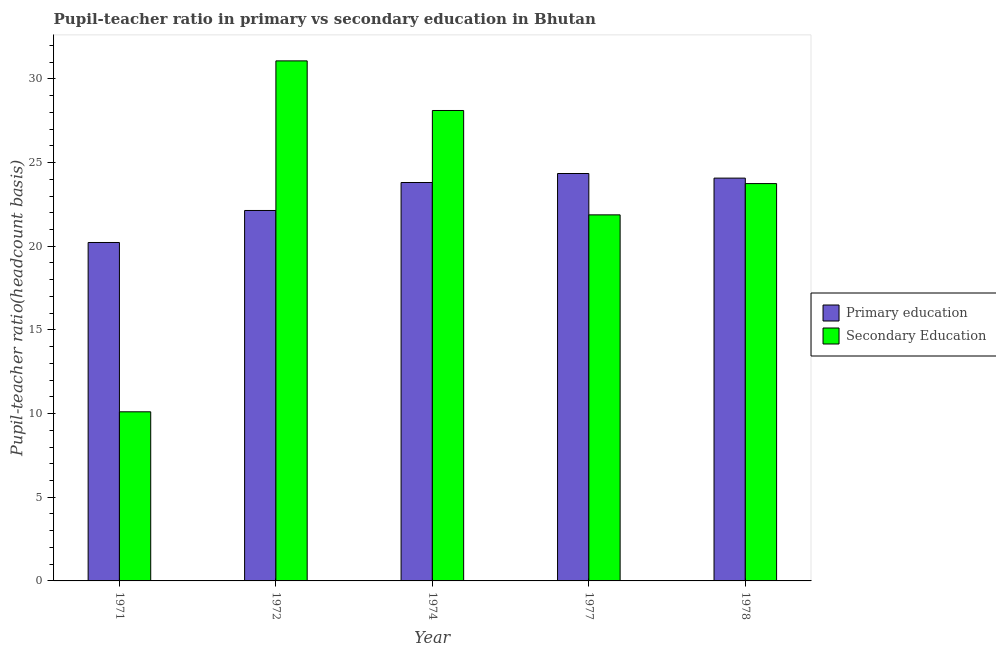How many groups of bars are there?
Ensure brevity in your answer.  5. How many bars are there on the 1st tick from the right?
Provide a succinct answer. 2. What is the label of the 3rd group of bars from the left?
Your answer should be compact. 1974. In how many cases, is the number of bars for a given year not equal to the number of legend labels?
Ensure brevity in your answer.  0. What is the pupil teacher ratio on secondary education in 1974?
Provide a succinct answer. 28.11. Across all years, what is the maximum pupil-teacher ratio in primary education?
Make the answer very short. 24.35. Across all years, what is the minimum pupil-teacher ratio in primary education?
Ensure brevity in your answer.  20.23. In which year was the pupil teacher ratio on secondary education minimum?
Your response must be concise. 1971. What is the total pupil-teacher ratio in primary education in the graph?
Provide a short and direct response. 114.6. What is the difference between the pupil teacher ratio on secondary education in 1974 and that in 1978?
Provide a succinct answer. 4.37. What is the difference between the pupil teacher ratio on secondary education in 1972 and the pupil-teacher ratio in primary education in 1977?
Provide a succinct answer. 9.2. What is the average pupil teacher ratio on secondary education per year?
Give a very brief answer. 22.98. In the year 1971, what is the difference between the pupil-teacher ratio in primary education and pupil teacher ratio on secondary education?
Ensure brevity in your answer.  0. In how many years, is the pupil-teacher ratio in primary education greater than 9?
Ensure brevity in your answer.  5. What is the ratio of the pupil-teacher ratio in primary education in 1974 to that in 1977?
Provide a succinct answer. 0.98. Is the difference between the pupil teacher ratio on secondary education in 1974 and 1977 greater than the difference between the pupil-teacher ratio in primary education in 1974 and 1977?
Offer a terse response. No. What is the difference between the highest and the second highest pupil teacher ratio on secondary education?
Provide a succinct answer. 2.96. What is the difference between the highest and the lowest pupil-teacher ratio in primary education?
Your response must be concise. 4.12. Is the sum of the pupil teacher ratio on secondary education in 1972 and 1977 greater than the maximum pupil-teacher ratio in primary education across all years?
Ensure brevity in your answer.  Yes. What does the 1st bar from the left in 1977 represents?
Your response must be concise. Primary education. What does the 2nd bar from the right in 1978 represents?
Offer a very short reply. Primary education. How many bars are there?
Keep it short and to the point. 10. Are all the bars in the graph horizontal?
Make the answer very short. No. How many years are there in the graph?
Keep it short and to the point. 5. What is the difference between two consecutive major ticks on the Y-axis?
Make the answer very short. 5. Does the graph contain grids?
Keep it short and to the point. No. How many legend labels are there?
Offer a terse response. 2. How are the legend labels stacked?
Offer a terse response. Vertical. What is the title of the graph?
Make the answer very short. Pupil-teacher ratio in primary vs secondary education in Bhutan. What is the label or title of the Y-axis?
Provide a short and direct response. Pupil-teacher ratio(headcount basis). What is the Pupil-teacher ratio(headcount basis) in Primary education in 1971?
Give a very brief answer. 20.23. What is the Pupil-teacher ratio(headcount basis) in Secondary Education in 1971?
Provide a short and direct response. 10.11. What is the Pupil-teacher ratio(headcount basis) in Primary education in 1972?
Provide a short and direct response. 22.14. What is the Pupil-teacher ratio(headcount basis) of Secondary Education in 1972?
Make the answer very short. 31.08. What is the Pupil-teacher ratio(headcount basis) of Primary education in 1974?
Offer a very short reply. 23.81. What is the Pupil-teacher ratio(headcount basis) of Secondary Education in 1974?
Your response must be concise. 28.11. What is the Pupil-teacher ratio(headcount basis) in Primary education in 1977?
Your response must be concise. 24.35. What is the Pupil-teacher ratio(headcount basis) of Secondary Education in 1977?
Offer a terse response. 21.88. What is the Pupil-teacher ratio(headcount basis) in Primary education in 1978?
Make the answer very short. 24.07. What is the Pupil-teacher ratio(headcount basis) of Secondary Education in 1978?
Your answer should be very brief. 23.75. Across all years, what is the maximum Pupil-teacher ratio(headcount basis) of Primary education?
Your answer should be very brief. 24.35. Across all years, what is the maximum Pupil-teacher ratio(headcount basis) of Secondary Education?
Make the answer very short. 31.08. Across all years, what is the minimum Pupil-teacher ratio(headcount basis) of Primary education?
Offer a terse response. 20.23. Across all years, what is the minimum Pupil-teacher ratio(headcount basis) in Secondary Education?
Your answer should be very brief. 10.11. What is the total Pupil-teacher ratio(headcount basis) in Primary education in the graph?
Make the answer very short. 114.6. What is the total Pupil-teacher ratio(headcount basis) of Secondary Education in the graph?
Provide a succinct answer. 114.92. What is the difference between the Pupil-teacher ratio(headcount basis) in Primary education in 1971 and that in 1972?
Ensure brevity in your answer.  -1.91. What is the difference between the Pupil-teacher ratio(headcount basis) of Secondary Education in 1971 and that in 1972?
Give a very brief answer. -20.97. What is the difference between the Pupil-teacher ratio(headcount basis) in Primary education in 1971 and that in 1974?
Make the answer very short. -3.58. What is the difference between the Pupil-teacher ratio(headcount basis) in Secondary Education in 1971 and that in 1974?
Your answer should be very brief. -18.01. What is the difference between the Pupil-teacher ratio(headcount basis) in Primary education in 1971 and that in 1977?
Ensure brevity in your answer.  -4.12. What is the difference between the Pupil-teacher ratio(headcount basis) of Secondary Education in 1971 and that in 1977?
Make the answer very short. -11.77. What is the difference between the Pupil-teacher ratio(headcount basis) of Primary education in 1971 and that in 1978?
Provide a succinct answer. -3.85. What is the difference between the Pupil-teacher ratio(headcount basis) of Secondary Education in 1971 and that in 1978?
Your answer should be very brief. -13.64. What is the difference between the Pupil-teacher ratio(headcount basis) in Primary education in 1972 and that in 1974?
Offer a terse response. -1.67. What is the difference between the Pupil-teacher ratio(headcount basis) in Secondary Education in 1972 and that in 1974?
Ensure brevity in your answer.  2.96. What is the difference between the Pupil-teacher ratio(headcount basis) in Primary education in 1972 and that in 1977?
Ensure brevity in your answer.  -2.21. What is the difference between the Pupil-teacher ratio(headcount basis) of Secondary Education in 1972 and that in 1977?
Provide a succinct answer. 9.2. What is the difference between the Pupil-teacher ratio(headcount basis) of Primary education in 1972 and that in 1978?
Give a very brief answer. -1.93. What is the difference between the Pupil-teacher ratio(headcount basis) of Secondary Education in 1972 and that in 1978?
Provide a short and direct response. 7.33. What is the difference between the Pupil-teacher ratio(headcount basis) in Primary education in 1974 and that in 1977?
Your answer should be compact. -0.54. What is the difference between the Pupil-teacher ratio(headcount basis) of Secondary Education in 1974 and that in 1977?
Ensure brevity in your answer.  6.24. What is the difference between the Pupil-teacher ratio(headcount basis) of Primary education in 1974 and that in 1978?
Offer a very short reply. -0.26. What is the difference between the Pupil-teacher ratio(headcount basis) of Secondary Education in 1974 and that in 1978?
Your answer should be compact. 4.37. What is the difference between the Pupil-teacher ratio(headcount basis) in Primary education in 1977 and that in 1978?
Keep it short and to the point. 0.28. What is the difference between the Pupil-teacher ratio(headcount basis) of Secondary Education in 1977 and that in 1978?
Offer a very short reply. -1.87. What is the difference between the Pupil-teacher ratio(headcount basis) of Primary education in 1971 and the Pupil-teacher ratio(headcount basis) of Secondary Education in 1972?
Ensure brevity in your answer.  -10.85. What is the difference between the Pupil-teacher ratio(headcount basis) in Primary education in 1971 and the Pupil-teacher ratio(headcount basis) in Secondary Education in 1974?
Offer a very short reply. -7.89. What is the difference between the Pupil-teacher ratio(headcount basis) of Primary education in 1971 and the Pupil-teacher ratio(headcount basis) of Secondary Education in 1977?
Provide a succinct answer. -1.65. What is the difference between the Pupil-teacher ratio(headcount basis) of Primary education in 1971 and the Pupil-teacher ratio(headcount basis) of Secondary Education in 1978?
Offer a terse response. -3.52. What is the difference between the Pupil-teacher ratio(headcount basis) of Primary education in 1972 and the Pupil-teacher ratio(headcount basis) of Secondary Education in 1974?
Make the answer very short. -5.98. What is the difference between the Pupil-teacher ratio(headcount basis) in Primary education in 1972 and the Pupil-teacher ratio(headcount basis) in Secondary Education in 1977?
Ensure brevity in your answer.  0.26. What is the difference between the Pupil-teacher ratio(headcount basis) of Primary education in 1972 and the Pupil-teacher ratio(headcount basis) of Secondary Education in 1978?
Your answer should be very brief. -1.61. What is the difference between the Pupil-teacher ratio(headcount basis) of Primary education in 1974 and the Pupil-teacher ratio(headcount basis) of Secondary Education in 1977?
Provide a short and direct response. 1.93. What is the difference between the Pupil-teacher ratio(headcount basis) of Primary education in 1974 and the Pupil-teacher ratio(headcount basis) of Secondary Education in 1978?
Keep it short and to the point. 0.06. What is the difference between the Pupil-teacher ratio(headcount basis) in Primary education in 1977 and the Pupil-teacher ratio(headcount basis) in Secondary Education in 1978?
Your response must be concise. 0.6. What is the average Pupil-teacher ratio(headcount basis) of Primary education per year?
Ensure brevity in your answer.  22.92. What is the average Pupil-teacher ratio(headcount basis) in Secondary Education per year?
Keep it short and to the point. 22.98. In the year 1971, what is the difference between the Pupil-teacher ratio(headcount basis) of Primary education and Pupil-teacher ratio(headcount basis) of Secondary Education?
Offer a very short reply. 10.12. In the year 1972, what is the difference between the Pupil-teacher ratio(headcount basis) of Primary education and Pupil-teacher ratio(headcount basis) of Secondary Education?
Offer a very short reply. -8.94. In the year 1974, what is the difference between the Pupil-teacher ratio(headcount basis) in Primary education and Pupil-teacher ratio(headcount basis) in Secondary Education?
Ensure brevity in your answer.  -4.3. In the year 1977, what is the difference between the Pupil-teacher ratio(headcount basis) in Primary education and Pupil-teacher ratio(headcount basis) in Secondary Education?
Your answer should be compact. 2.47. In the year 1978, what is the difference between the Pupil-teacher ratio(headcount basis) of Primary education and Pupil-teacher ratio(headcount basis) of Secondary Education?
Your answer should be very brief. 0.33. What is the ratio of the Pupil-teacher ratio(headcount basis) of Primary education in 1971 to that in 1972?
Your answer should be compact. 0.91. What is the ratio of the Pupil-teacher ratio(headcount basis) in Secondary Education in 1971 to that in 1972?
Your answer should be compact. 0.33. What is the ratio of the Pupil-teacher ratio(headcount basis) of Primary education in 1971 to that in 1974?
Provide a short and direct response. 0.85. What is the ratio of the Pupil-teacher ratio(headcount basis) of Secondary Education in 1971 to that in 1974?
Offer a very short reply. 0.36. What is the ratio of the Pupil-teacher ratio(headcount basis) in Primary education in 1971 to that in 1977?
Give a very brief answer. 0.83. What is the ratio of the Pupil-teacher ratio(headcount basis) in Secondary Education in 1971 to that in 1977?
Keep it short and to the point. 0.46. What is the ratio of the Pupil-teacher ratio(headcount basis) in Primary education in 1971 to that in 1978?
Give a very brief answer. 0.84. What is the ratio of the Pupil-teacher ratio(headcount basis) of Secondary Education in 1971 to that in 1978?
Make the answer very short. 0.43. What is the ratio of the Pupil-teacher ratio(headcount basis) of Primary education in 1972 to that in 1974?
Provide a succinct answer. 0.93. What is the ratio of the Pupil-teacher ratio(headcount basis) of Secondary Education in 1972 to that in 1974?
Give a very brief answer. 1.11. What is the ratio of the Pupil-teacher ratio(headcount basis) in Primary education in 1972 to that in 1977?
Make the answer very short. 0.91. What is the ratio of the Pupil-teacher ratio(headcount basis) in Secondary Education in 1972 to that in 1977?
Your answer should be very brief. 1.42. What is the ratio of the Pupil-teacher ratio(headcount basis) in Primary education in 1972 to that in 1978?
Your answer should be compact. 0.92. What is the ratio of the Pupil-teacher ratio(headcount basis) of Secondary Education in 1972 to that in 1978?
Ensure brevity in your answer.  1.31. What is the ratio of the Pupil-teacher ratio(headcount basis) in Primary education in 1974 to that in 1977?
Provide a short and direct response. 0.98. What is the ratio of the Pupil-teacher ratio(headcount basis) of Secondary Education in 1974 to that in 1977?
Provide a succinct answer. 1.29. What is the ratio of the Pupil-teacher ratio(headcount basis) in Secondary Education in 1974 to that in 1978?
Provide a short and direct response. 1.18. What is the ratio of the Pupil-teacher ratio(headcount basis) of Primary education in 1977 to that in 1978?
Make the answer very short. 1.01. What is the ratio of the Pupil-teacher ratio(headcount basis) of Secondary Education in 1977 to that in 1978?
Keep it short and to the point. 0.92. What is the difference between the highest and the second highest Pupil-teacher ratio(headcount basis) in Primary education?
Ensure brevity in your answer.  0.28. What is the difference between the highest and the second highest Pupil-teacher ratio(headcount basis) of Secondary Education?
Provide a succinct answer. 2.96. What is the difference between the highest and the lowest Pupil-teacher ratio(headcount basis) of Primary education?
Your answer should be very brief. 4.12. What is the difference between the highest and the lowest Pupil-teacher ratio(headcount basis) in Secondary Education?
Make the answer very short. 20.97. 